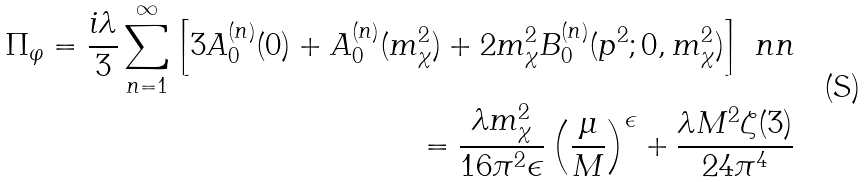Convert formula to latex. <formula><loc_0><loc_0><loc_500><loc_500>\Pi _ { \varphi } = \frac { i \lambda } { 3 } \sum _ { n = 1 } ^ { \infty } \left [ 3 A _ { 0 } ^ { ( n ) } ( 0 ) + A _ { 0 } ^ { ( n ) } ( m _ { \chi } ^ { 2 } ) + 2 m _ { \chi } ^ { 2 } B _ { 0 } ^ { ( n ) } ( p ^ { 2 } ; 0 , m _ { \chi } ^ { 2 } ) \right ] \ n n \\ = \frac { \lambda m _ { \chi } ^ { 2 } } { 1 6 \pi ^ { 2 } \epsilon } \left ( \frac { \mu } { M } \right ) ^ { \epsilon } + \frac { \lambda M ^ { 2 } \zeta ( 3 ) } { 2 4 \pi ^ { 4 } }</formula> 